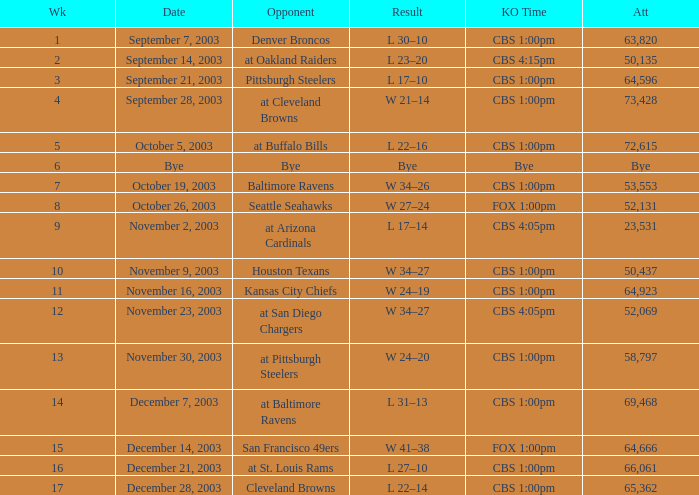What is the average number of weeks that the opponent was the Denver Broncos? 1.0. 